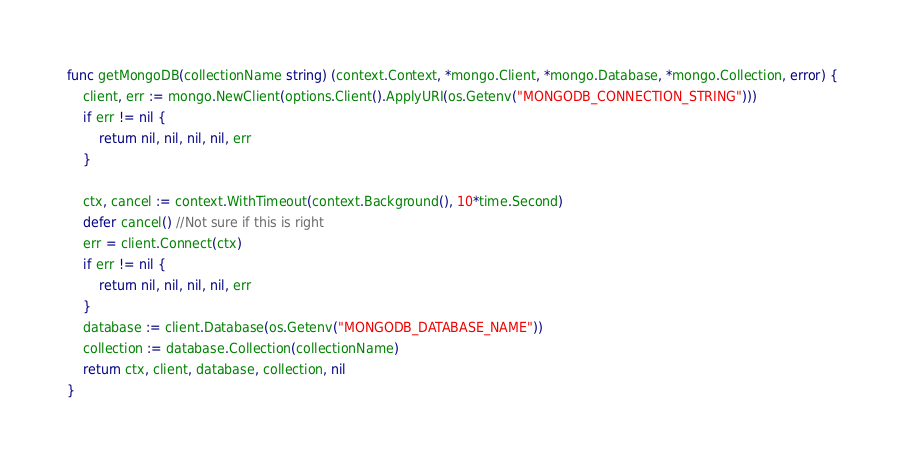<code> <loc_0><loc_0><loc_500><loc_500><_Go_>func getMongoDB(collectionName string) (context.Context, *mongo.Client, *mongo.Database, *mongo.Collection, error) {
	client, err := mongo.NewClient(options.Client().ApplyURI(os.Getenv("MONGODB_CONNECTION_STRING")))
	if err != nil {
		return nil, nil, nil, nil, err
	}

	ctx, cancel := context.WithTimeout(context.Background(), 10*time.Second)
	defer cancel() //Not sure if this is right
	err = client.Connect(ctx)
	if err != nil {
		return nil, nil, nil, nil, err
	}
	database := client.Database(os.Getenv("MONGODB_DATABASE_NAME"))
	collection := database.Collection(collectionName)
	return ctx, client, database, collection, nil
}
</code> 